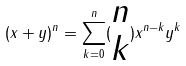Convert formula to latex. <formula><loc_0><loc_0><loc_500><loc_500>( x + y ) ^ { n } = \sum _ { k = 0 } ^ { n } ( \begin{matrix} n \\ k \end{matrix} ) x ^ { n - k } y ^ { k }</formula> 